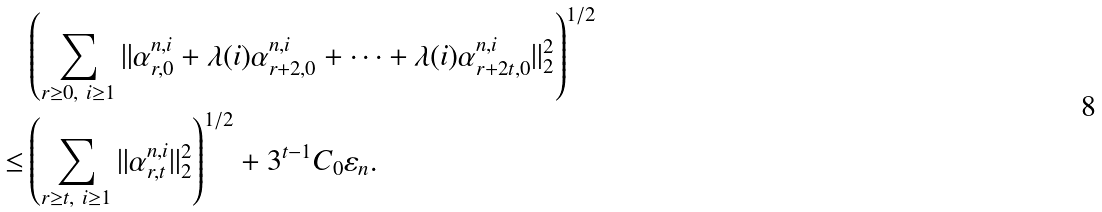Convert formula to latex. <formula><loc_0><loc_0><loc_500><loc_500>& \left ( \sum _ { \substack { r \geq 0 , \ i \geq 1 } } \| \alpha ^ { n , i } _ { r , 0 } + \lambda ( i ) \alpha ^ { n , i } _ { r + 2 , 0 } + \dots + \lambda ( i ) \alpha ^ { n , i } _ { r + 2 t , 0 } \| _ { 2 } ^ { 2 } \right ) ^ { 1 / 2 } \\ \leq & \left ( \sum _ { \substack { r \geq t , \ i \geq 1 } } \| \alpha ^ { n , i } _ { r , t } \| _ { 2 } ^ { 2 } \right ) ^ { 1 / 2 } + 3 ^ { t - 1 } C _ { 0 } \varepsilon _ { n } .</formula> 